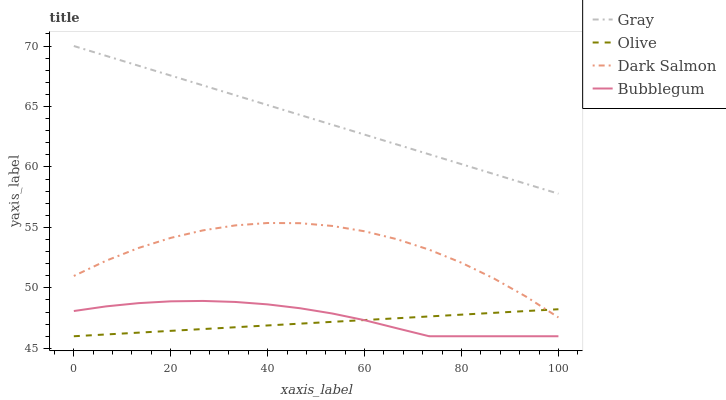Does Olive have the minimum area under the curve?
Answer yes or no. Yes. Does Gray have the maximum area under the curve?
Answer yes or no. Yes. Does Dark Salmon have the minimum area under the curve?
Answer yes or no. No. Does Dark Salmon have the maximum area under the curve?
Answer yes or no. No. Is Olive the smoothest?
Answer yes or no. Yes. Is Dark Salmon the roughest?
Answer yes or no. Yes. Is Gray the smoothest?
Answer yes or no. No. Is Gray the roughest?
Answer yes or no. No. Does Olive have the lowest value?
Answer yes or no. Yes. Does Dark Salmon have the lowest value?
Answer yes or no. No. Does Gray have the highest value?
Answer yes or no. Yes. Does Dark Salmon have the highest value?
Answer yes or no. No. Is Olive less than Gray?
Answer yes or no. Yes. Is Gray greater than Dark Salmon?
Answer yes or no. Yes. Does Olive intersect Dark Salmon?
Answer yes or no. Yes. Is Olive less than Dark Salmon?
Answer yes or no. No. Is Olive greater than Dark Salmon?
Answer yes or no. No. Does Olive intersect Gray?
Answer yes or no. No. 